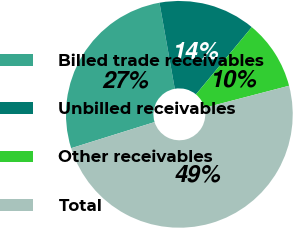Convert chart to OTSL. <chart><loc_0><loc_0><loc_500><loc_500><pie_chart><fcel>Billed trade receivables<fcel>Unbilled receivables<fcel>Other receivables<fcel>Total<nl><fcel>27.02%<fcel>13.84%<fcel>9.91%<fcel>49.23%<nl></chart> 